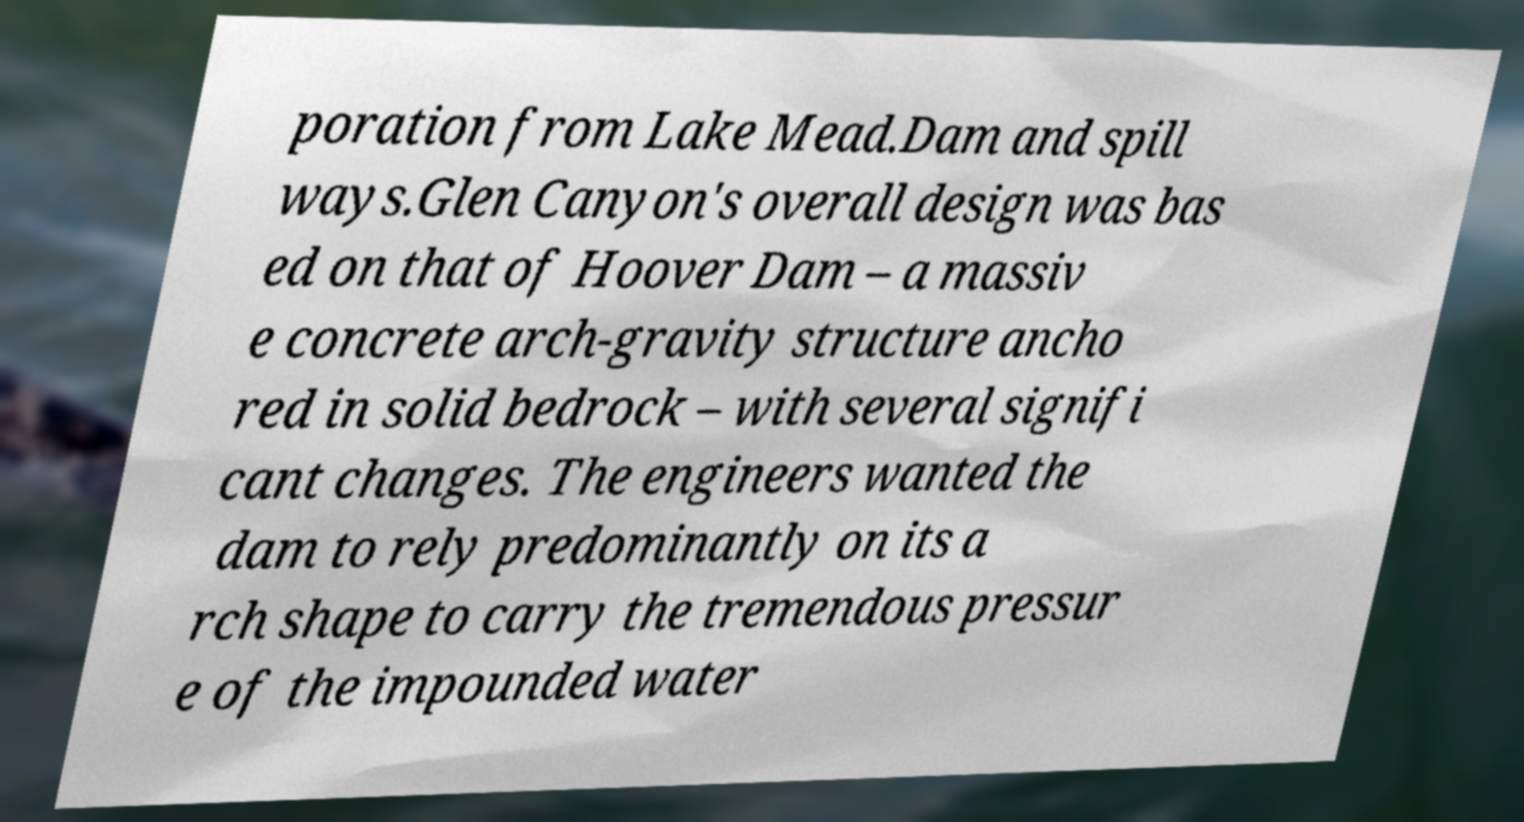There's text embedded in this image that I need extracted. Can you transcribe it verbatim? poration from Lake Mead.Dam and spill ways.Glen Canyon's overall design was bas ed on that of Hoover Dam – a massiv e concrete arch-gravity structure ancho red in solid bedrock – with several signifi cant changes. The engineers wanted the dam to rely predominantly on its a rch shape to carry the tremendous pressur e of the impounded water 